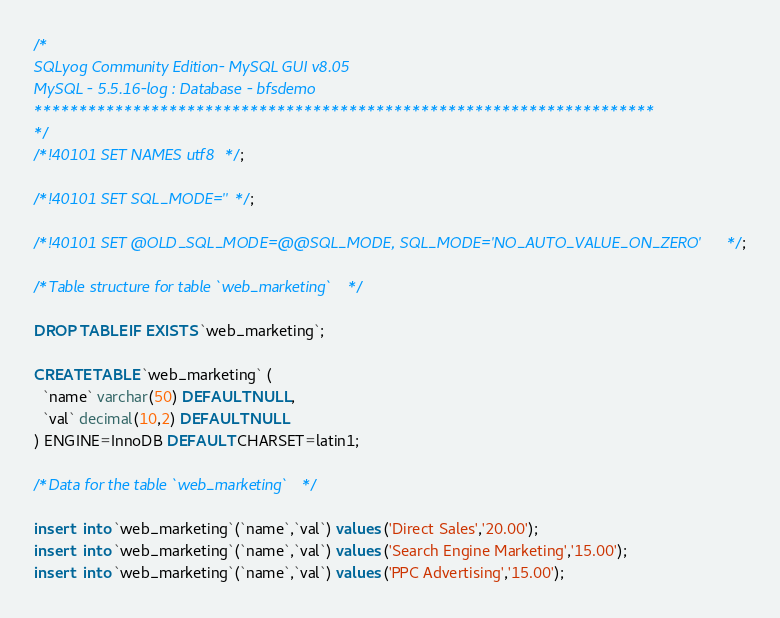Convert code to text. <code><loc_0><loc_0><loc_500><loc_500><_SQL_>/*
SQLyog Community Edition- MySQL GUI v8.05 
MySQL - 5.5.16-log : Database - bfsdemo
*********************************************************************
*/
/*!40101 SET NAMES utf8 */;

/*!40101 SET SQL_MODE=''*/;

/*!40101 SET @OLD_SQL_MODE=@@SQL_MODE, SQL_MODE='NO_AUTO_VALUE_ON_ZERO' */;

/*Table structure for table `web_marketing` */

DROP TABLE IF EXISTS `web_marketing`;

CREATE TABLE `web_marketing` (
  `name` varchar(50) DEFAULT NULL,
  `val` decimal(10,2) DEFAULT NULL
) ENGINE=InnoDB DEFAULT CHARSET=latin1;

/*Data for the table `web_marketing` */

insert  into `web_marketing`(`name`,`val`) values ('Direct Sales','20.00');
insert  into `web_marketing`(`name`,`val`) values ('Search Engine Marketing','15.00');
insert  into `web_marketing`(`name`,`val`) values ('PPC Advertising','15.00');</code> 